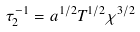Convert formula to latex. <formula><loc_0><loc_0><loc_500><loc_500>\tau _ { 2 } ^ { - 1 } = a ^ { 1 / 2 } T ^ { 1 / 2 } \chi ^ { 3 / 2 }</formula> 